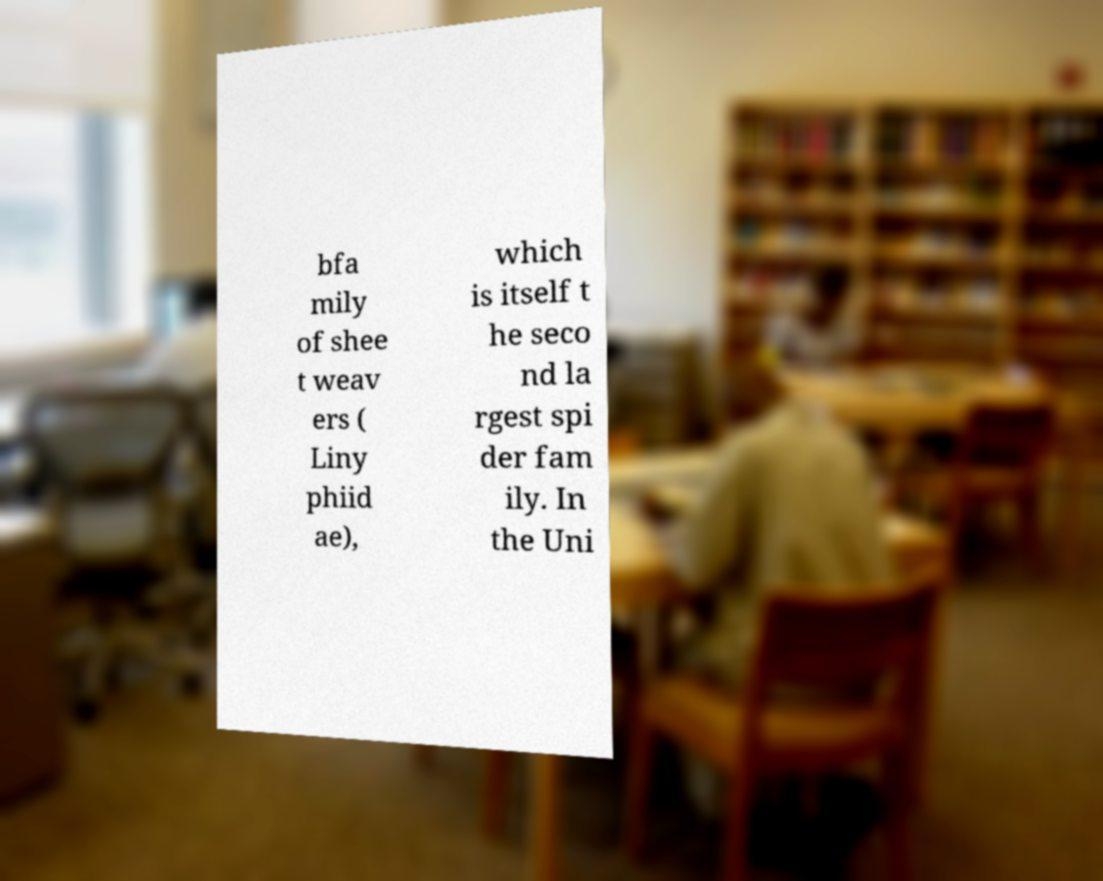Could you assist in decoding the text presented in this image and type it out clearly? bfa mily of shee t weav ers ( Liny phiid ae), which is itself t he seco nd la rgest spi der fam ily. In the Uni 